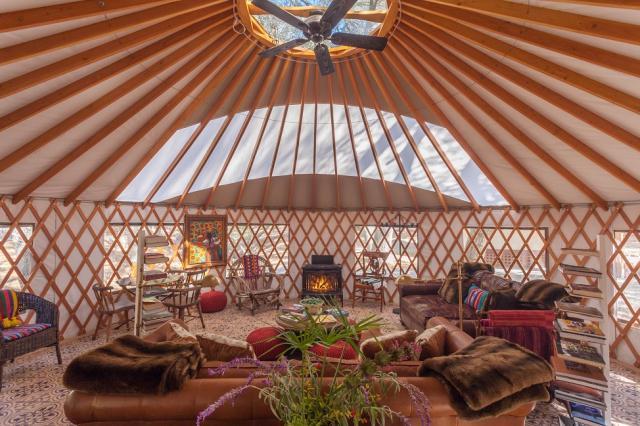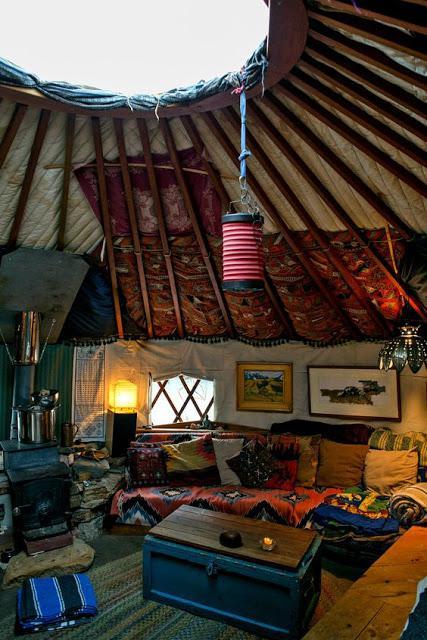The first image is the image on the left, the second image is the image on the right. Examine the images to the left and right. Is the description "One of the images shows a second floor balcony area with a wooden railing." accurate? Answer yes or no. No. 